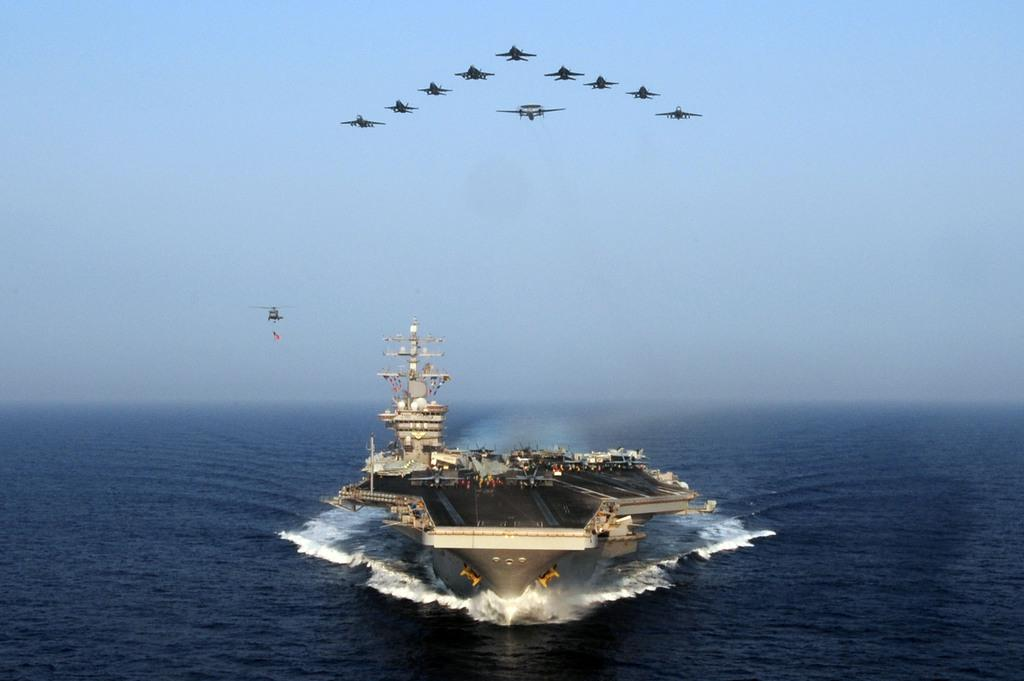What is the main subject of the image? The main subject of the image is a ship. Where is the ship located? The ship is on the ocean. What else can be seen in the image besides the ship? Flights are visible in the image. What is visible at the top of the image? The sky is visible at the top of the image. What type of print can be seen on the side of the van in the image? There is no van present in the image, so there is no print to observe. 